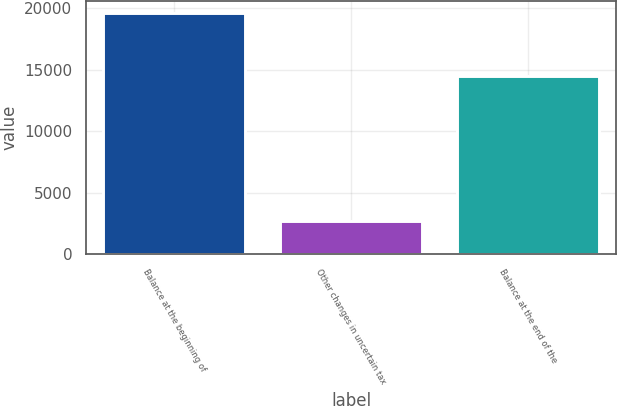Convert chart to OTSL. <chart><loc_0><loc_0><loc_500><loc_500><bar_chart><fcel>Balance at the beginning of<fcel>Other changes in uncertain tax<fcel>Balance at the end of the<nl><fcel>19596<fcel>2741<fcel>14450<nl></chart> 